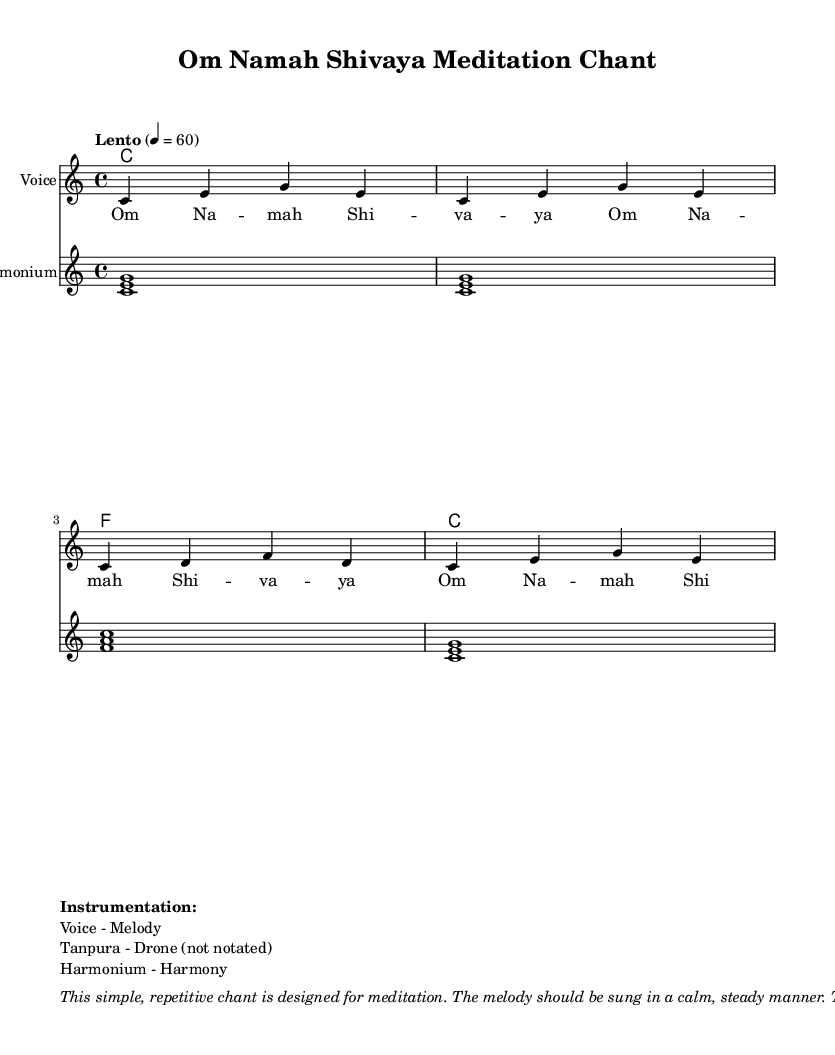What is the key signature of this music? The key signature is C major, which has no sharps or flats.
Answer: C major What is the time signature of this piece? The time signature is indicated as 4/4, meaning there are four beats per measure.
Answer: 4/4 What is the tempo marking given in the score? The tempo marking "Lento" indicates a slow tempo, specifically at a speed of 60 beats per minute.
Answer: Lento How many times is the chant "Om Namah Shivaya" repeated in the lyrics? The chant appears four times in the lyrics section, as indicated by the repetition in the text.
Answer: Four What instruments are listed in the instrumentation section? The instrumentation mentions a voice for the melody, tanpura for drone (not notated), and harmonium for harmony.
Answer: Voice, Tanpura, Harmonium What is the purpose of this chant as mentioned in the markup? The markup describes the purpose of the chant as being designed for meditation, indicating its use in calming and centering practices.
Answer: Meditation 